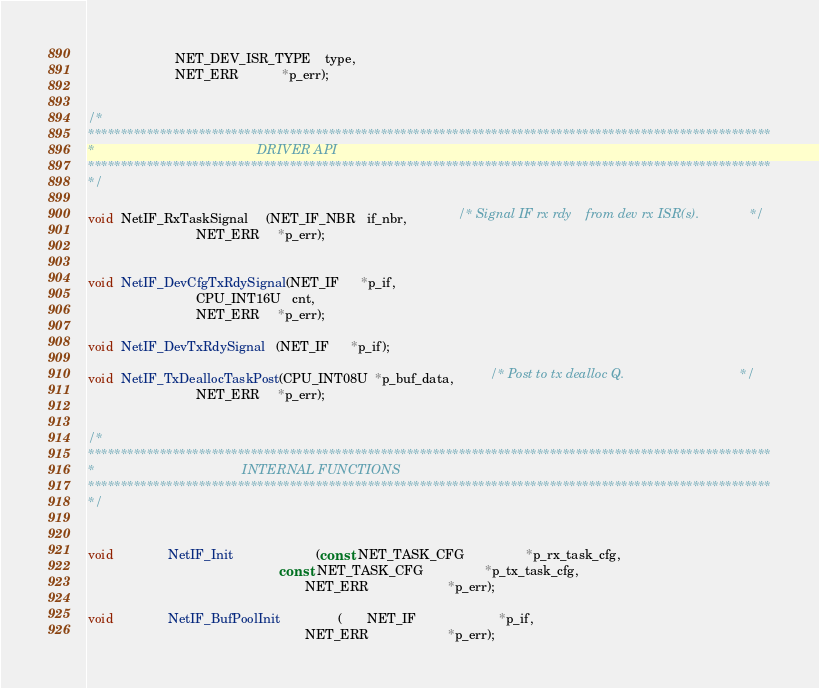<code> <loc_0><loc_0><loc_500><loc_500><_C_>                        NET_DEV_ISR_TYPE    type,
                        NET_ERR            *p_err);


/*
*********************************************************************************************************
*                                             DRIVER API
*********************************************************************************************************
*/

void  NetIF_RxTaskSignal     (NET_IF_NBR   if_nbr,              /* Signal IF rx rdy    from dev rx ISR(s).              */
                              NET_ERR     *p_err);


void  NetIF_DevCfgTxRdySignal(NET_IF      *p_if,
                              CPU_INT16U   cnt,
                              NET_ERR     *p_err);

void  NetIF_DevTxRdySignal   (NET_IF      *p_if);

void  NetIF_TxDeallocTaskPost(CPU_INT08U  *p_buf_data,          /* Post to tx dealloc Q.                                */
                              NET_ERR     *p_err);


/*
*********************************************************************************************************
*                                         INTERNAL FUNCTIONS
*********************************************************************************************************
*/


void               NetIF_Init                       (const  NET_TASK_CFG                 *p_rx_task_cfg,
                                                     const  NET_TASK_CFG                 *p_tx_task_cfg,
                                                            NET_ERR                      *p_err);

void               NetIF_BufPoolInit                (       NET_IF                       *p_if,
                                                            NET_ERR                      *p_err);

</code> 